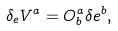<formula> <loc_0><loc_0><loc_500><loc_500>\delta _ { e } V ^ { a } = O _ { b } ^ { a } \delta e ^ { b } ,</formula> 